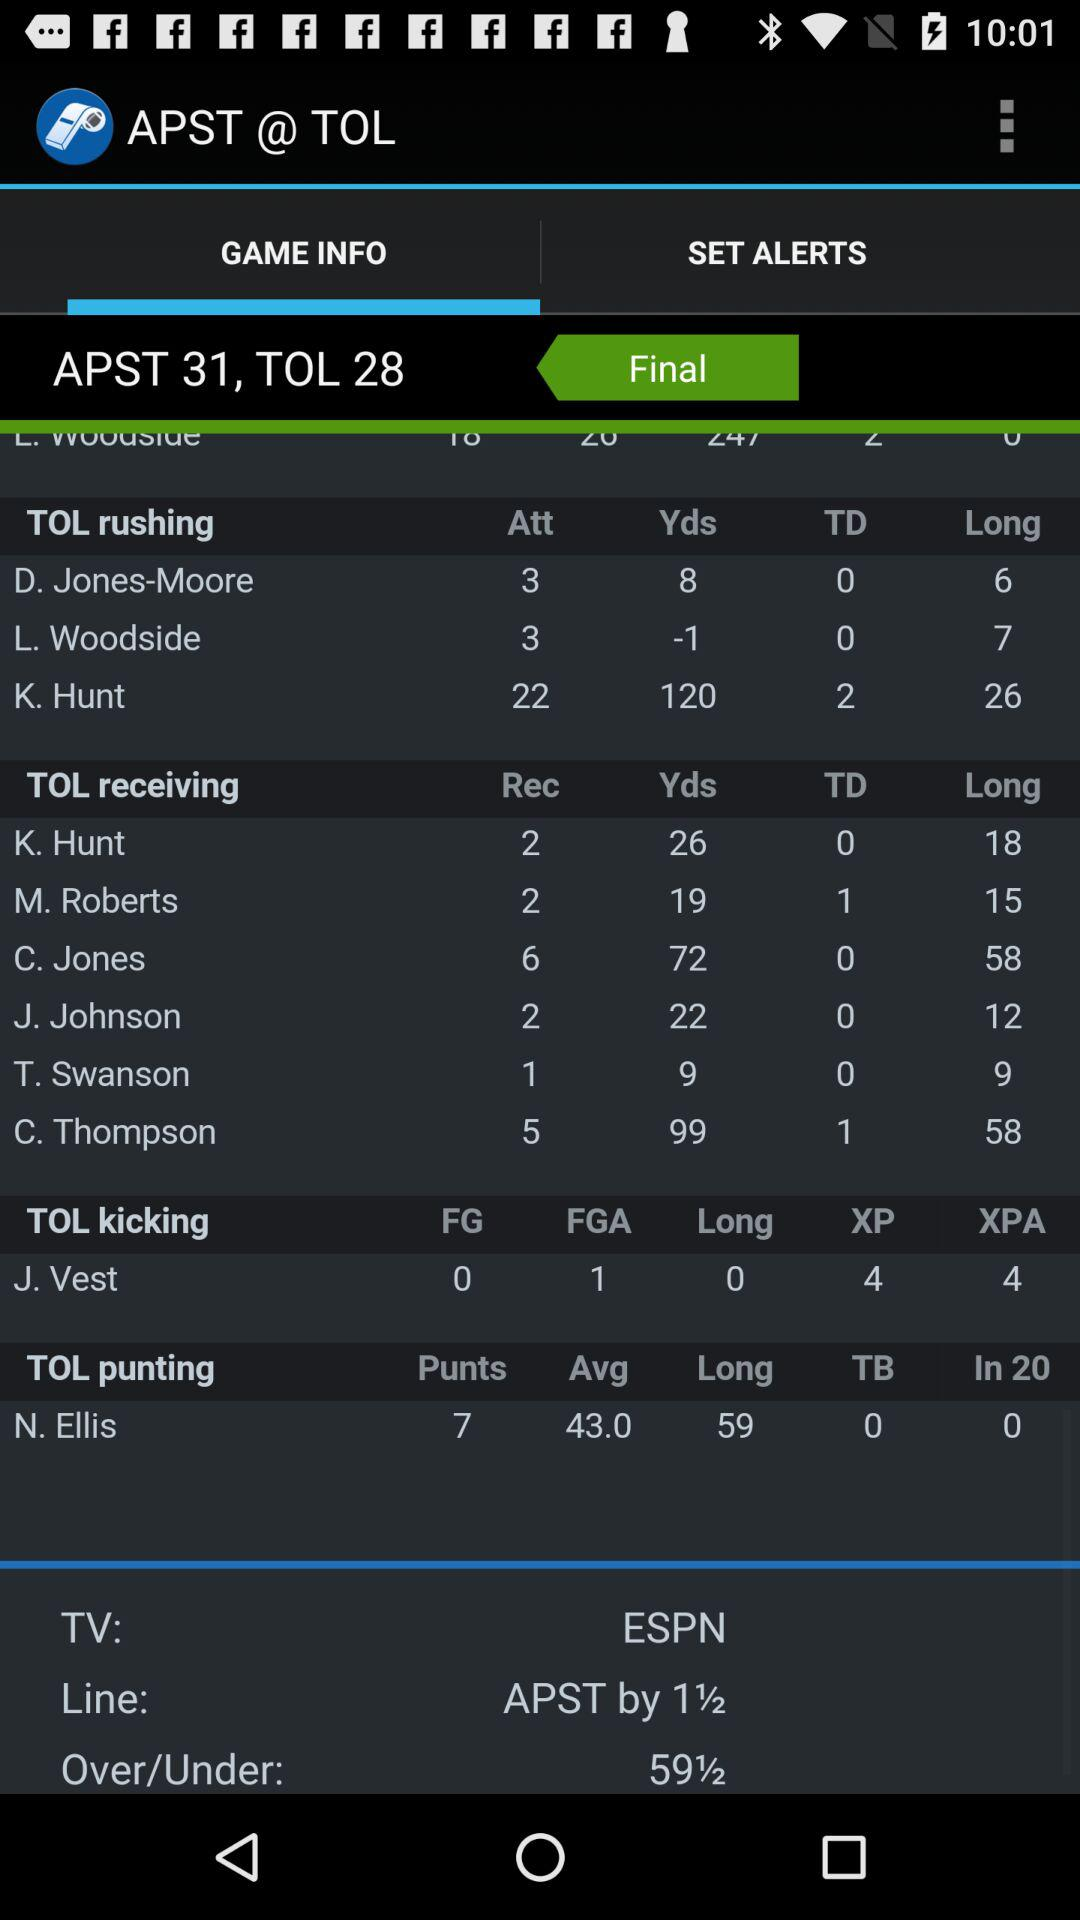What is the given TV channel? The given TV channel is "ESPN". 